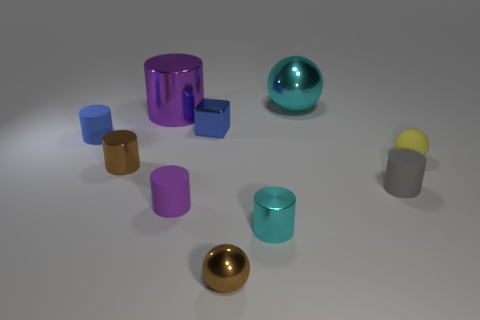Is there anything else that is the same shape as the blue metal thing?
Your answer should be compact. No. Is the material of the cyan thing on the left side of the big cyan object the same as the cyan ball?
Your answer should be very brief. Yes. The sphere that is both left of the small yellow matte sphere and in front of the cyan shiny ball is made of what material?
Offer a terse response. Metal. There is a object that is the same color as the big shiny cylinder; what size is it?
Offer a very short reply. Small. The small yellow sphere that is to the right of the cyan shiny object in front of the tiny yellow sphere is made of what material?
Ensure brevity in your answer.  Rubber. There is a brown metallic thing right of the large metal cylinder behind the metal ball in front of the small brown cylinder; what is its size?
Make the answer very short. Small. How many large purple cylinders have the same material as the cube?
Make the answer very short. 1. There is a tiny thing that is on the left side of the small brown thing that is behind the small cyan metal cylinder; what is its color?
Offer a very short reply. Blue. How many objects are either tiny blue objects or rubber things to the left of the yellow thing?
Offer a very short reply. 4. Is there a large sphere of the same color as the tiny metal sphere?
Give a very brief answer. No. 